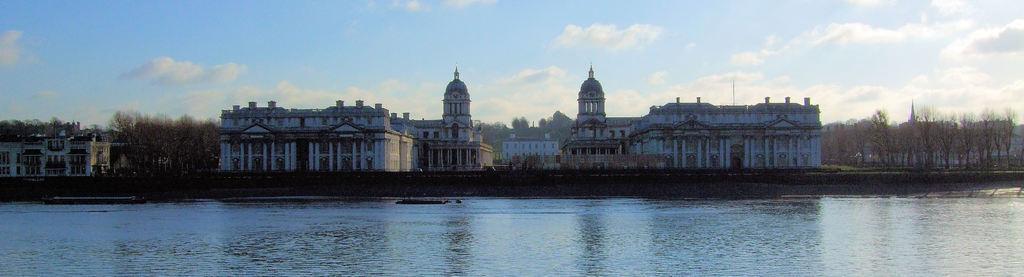Please provide a concise description of this image. In this image we can see buildings with windows, trees, water and in the background we can see the sky. 